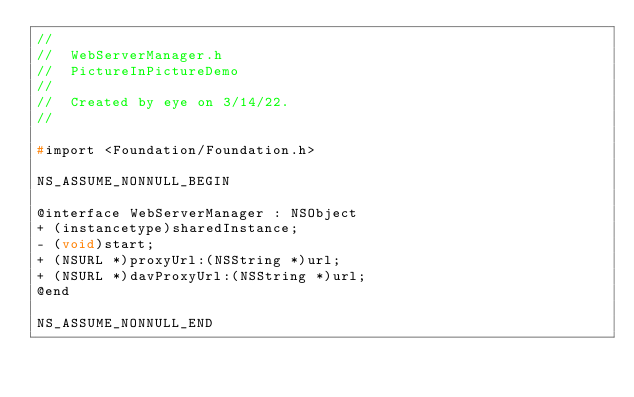Convert code to text. <code><loc_0><loc_0><loc_500><loc_500><_C_>//
//  WebServerManager.h
//  PictureInPictureDemo
//
//  Created by eye on 3/14/22.
//

#import <Foundation/Foundation.h>

NS_ASSUME_NONNULL_BEGIN

@interface WebServerManager : NSObject
+ (instancetype)sharedInstance;
- (void)start;
+ (NSURL *)proxyUrl:(NSString *)url;
+ (NSURL *)davProxyUrl:(NSString *)url;
@end

NS_ASSUME_NONNULL_END
</code> 